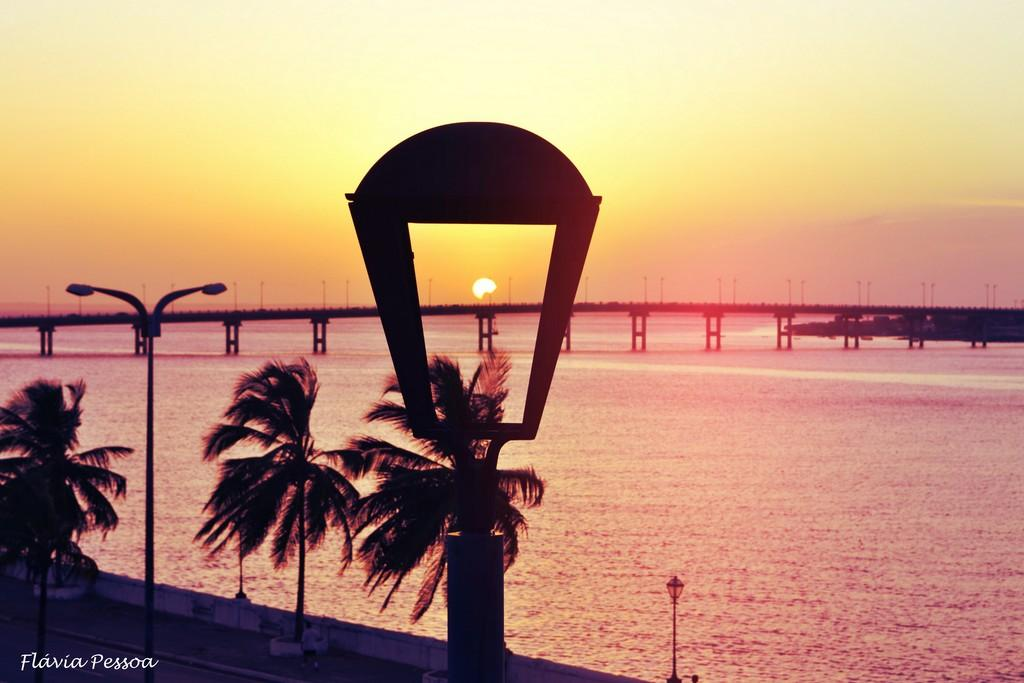What type of natural elements can be seen in the image? There are trees and water visible in the image. What type of man-made structures are present in the image? There are lights, poles, and a bridge in the image. What is the background of the image? The sky is visible in the background of the image. What additional feature can be observed on the image? There is a watermark on the image. Reasoning: Let' Let's think step by step in order to produce the conversation. We start by identifying the natural elements in the image, which are the trees and water. Then, we focus on the man-made structures, such as the lights, poles, and bridge. We also mention the sky in the background and the presence of a watermark on the image. Each question is designed to elicit a specific detail about the image that is known from the provided facts. Absurd Question/Answer: How does the water in the image taste? The taste of the water cannot be determined from the image, as taste is not a visual characteristic. 